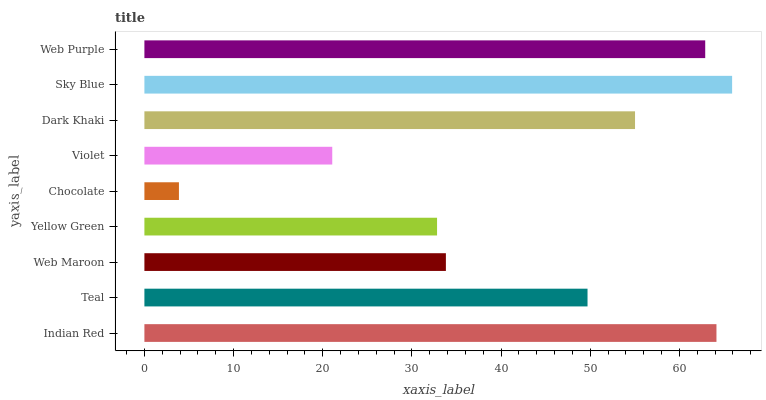Is Chocolate the minimum?
Answer yes or no. Yes. Is Sky Blue the maximum?
Answer yes or no. Yes. Is Teal the minimum?
Answer yes or no. No. Is Teal the maximum?
Answer yes or no. No. Is Indian Red greater than Teal?
Answer yes or no. Yes. Is Teal less than Indian Red?
Answer yes or no. Yes. Is Teal greater than Indian Red?
Answer yes or no. No. Is Indian Red less than Teal?
Answer yes or no. No. Is Teal the high median?
Answer yes or no. Yes. Is Teal the low median?
Answer yes or no. Yes. Is Chocolate the high median?
Answer yes or no. No. Is Dark Khaki the low median?
Answer yes or no. No. 